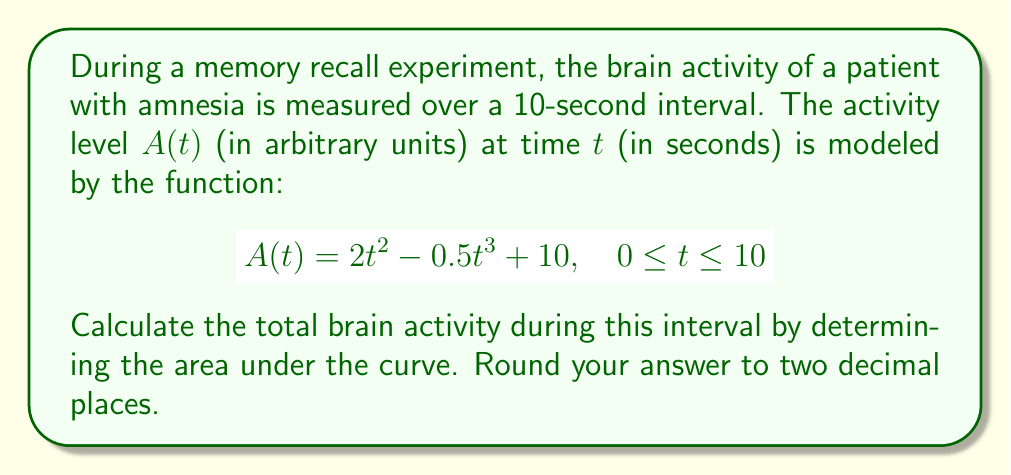Help me with this question. To find the total brain activity, we need to calculate the area under the curve of $A(t)$ from $t=0$ to $t=10$. This can be done using a definite integral.

1) Set up the integral:
   $$\int_0^{10} (2t^2 - 0.5t^3 + 10) dt$$

2) Integrate each term:
   $$\left[ \frac{2t^3}{3} - \frac{0.5t^4}{4} + 10t \right]_0^{10}$$

3) Evaluate the antiderivative at the upper and lower limits:
   $$\left(\frac{2(10^3)}{3} - \frac{0.5(10^4)}{4} + 10(10)\right) - \left(\frac{2(0^3)}{3} - \frac{0.5(0^4)}{4} + 10(0)\right)$$

4) Simplify:
   $$\left(\frac{2000}{3} - 1250 + 100\right) - 0$$
   $$\frac{2000}{3} - 1150$$
   $$666.67 - 1150 = -483.33$$

5) The negative result is because the curve dips below the x-axis. Since we're measuring total activity, we take the absolute value:
   $$||-483.33|| = 483.33$$

6) Round to two decimal places: 483.33

Therefore, the total brain activity during the 10-second interval is 483.33 arbitrary units.
Answer: 483.33 arbitrary units 